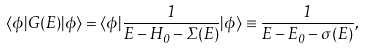Convert formula to latex. <formula><loc_0><loc_0><loc_500><loc_500>\langle \phi | G ( E ) | \phi \rangle = \langle \phi | \frac { 1 } { E - H _ { 0 } - \Sigma ( E ) } | \phi \rangle \equiv \frac { 1 } { E - E _ { 0 } - \sigma ( E ) } ,</formula> 